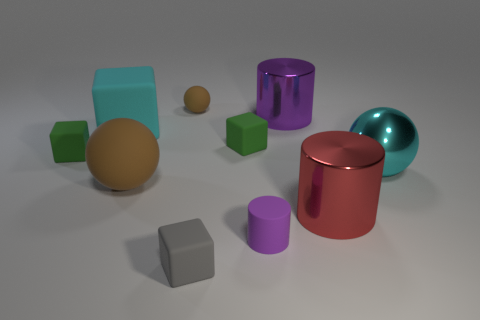Subtract all tiny rubber balls. How many balls are left? 2 Subtract all gray blocks. How many blocks are left? 3 Subtract 2 cylinders. How many cylinders are left? 1 Subtract all spheres. How many objects are left? 7 Subtract 0 purple cubes. How many objects are left? 10 Subtract all yellow spheres. Subtract all brown blocks. How many spheres are left? 3 Subtract all green cylinders. How many brown spheres are left? 2 Subtract all cyan metal balls. Subtract all big cyan things. How many objects are left? 7 Add 7 cylinders. How many cylinders are left? 10 Add 6 big green metal balls. How many big green metal balls exist? 6 